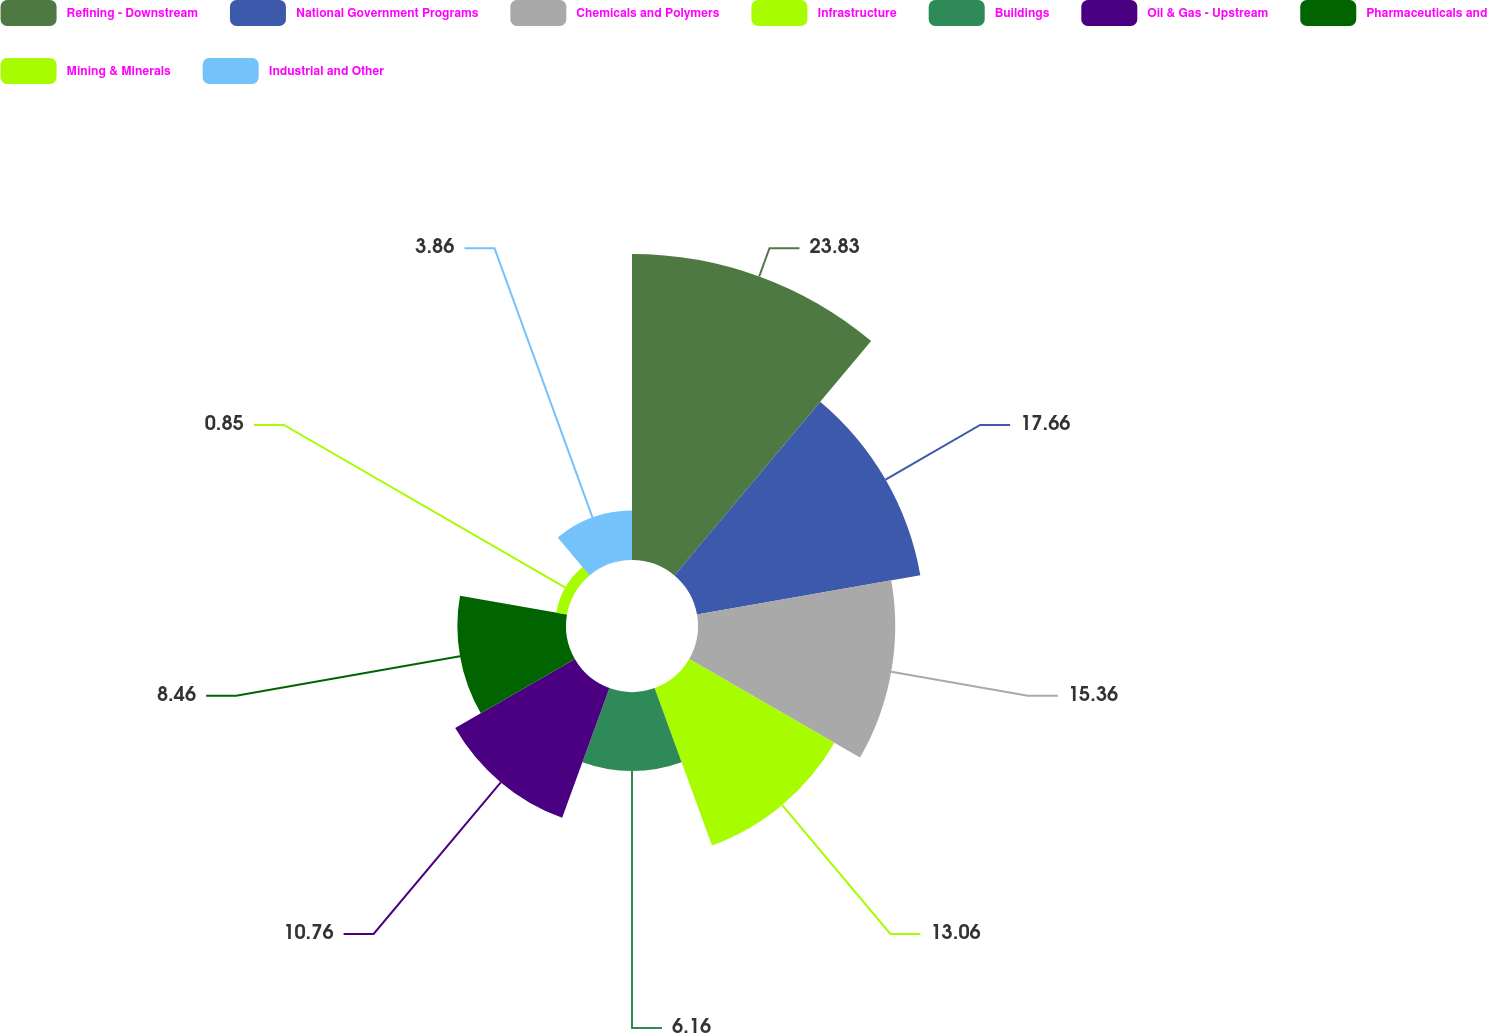<chart> <loc_0><loc_0><loc_500><loc_500><pie_chart><fcel>Refining - Downstream<fcel>National Government Programs<fcel>Chemicals and Polymers<fcel>Infrastructure<fcel>Buildings<fcel>Oil & Gas - Upstream<fcel>Pharmaceuticals and<fcel>Mining & Minerals<fcel>Industrial and Other<nl><fcel>23.83%<fcel>17.66%<fcel>15.36%<fcel>13.06%<fcel>6.16%<fcel>10.76%<fcel>8.46%<fcel>0.85%<fcel>3.86%<nl></chart> 